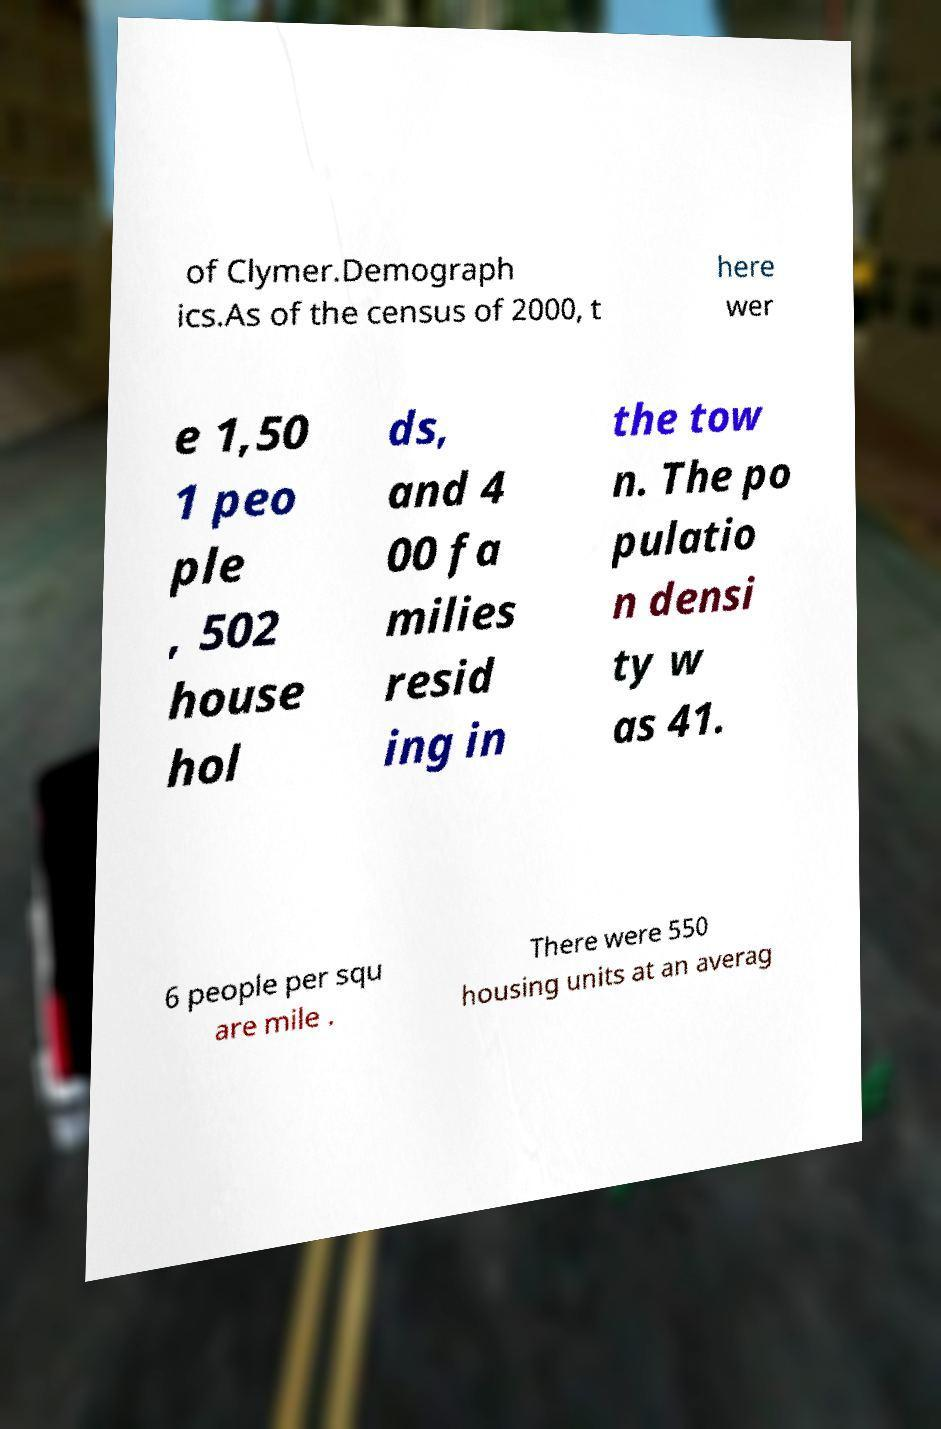Please read and relay the text visible in this image. What does it say? of Clymer.Demograph ics.As of the census of 2000, t here wer e 1,50 1 peo ple , 502 house hol ds, and 4 00 fa milies resid ing in the tow n. The po pulatio n densi ty w as 41. 6 people per squ are mile . There were 550 housing units at an averag 